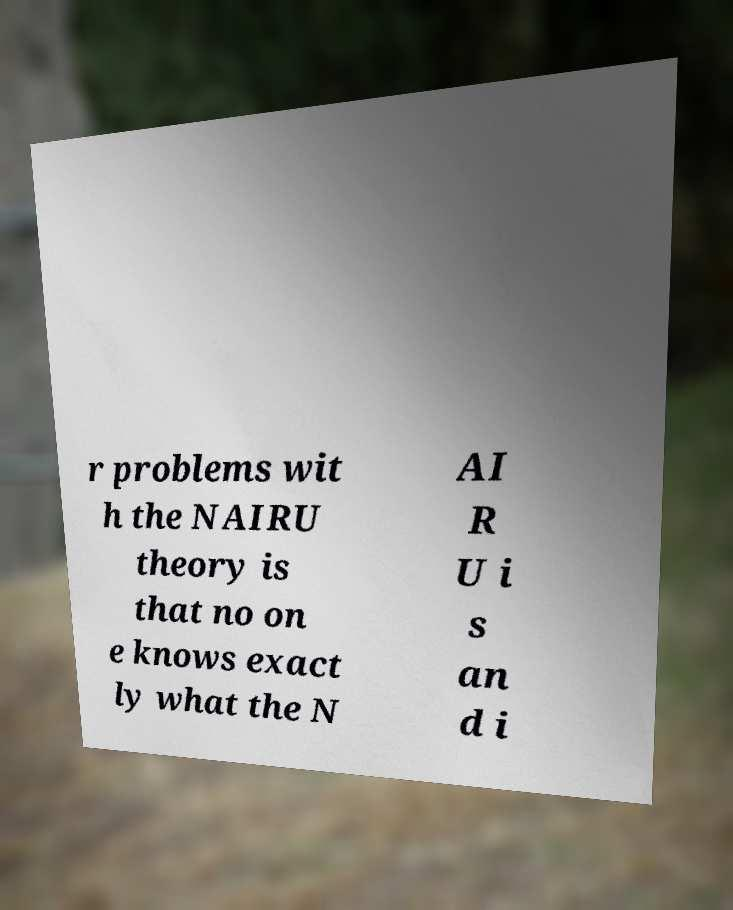There's text embedded in this image that I need extracted. Can you transcribe it verbatim? r problems wit h the NAIRU theory is that no on e knows exact ly what the N AI R U i s an d i 